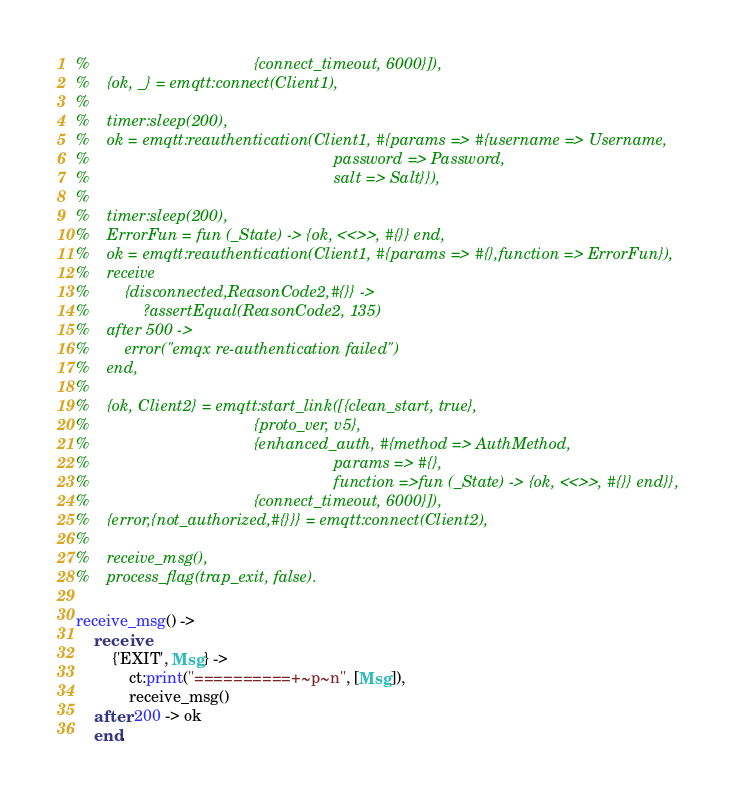<code> <loc_0><loc_0><loc_500><loc_500><_Erlang_>%                                     {connect_timeout, 6000}]),
%    {ok, _} = emqtt:connect(Client1),
%
%    timer:sleep(200),
%    ok = emqtt:reauthentication(Client1, #{params => #{username => Username,
%                                                       password => Password,
%                                                       salt => Salt}}),
%
%    timer:sleep(200),
%    ErrorFun = fun (_State) -> {ok, <<>>, #{}} end,
%    ok = emqtt:reauthentication(Client1, #{params => #{},function => ErrorFun}),
%    receive
%        {disconnected,ReasonCode2,#{}} ->
%            ?assertEqual(ReasonCode2, 135)
%    after 500 ->
%        error("emqx re-authentication failed")
%    end,
%
%    {ok, Client2} = emqtt:start_link([{clean_start, true},
%                                     {proto_ver, v5},
%                                     {enhanced_auth, #{method => AuthMethod,
%                                                       params => #{},
%                                                       function =>fun (_State) -> {ok, <<>>, #{}} end}},
%                                     {connect_timeout, 6000}]),
%    {error,{not_authorized,#{}}} = emqtt:connect(Client2),
%
%    receive_msg(),
%    process_flag(trap_exit, false).

receive_msg() ->
    receive
        {'EXIT', Msg} -> 
            ct:print("==========+~p~n", [Msg]), 
            receive_msg()
    after 200 -> ok
    end.
</code> 